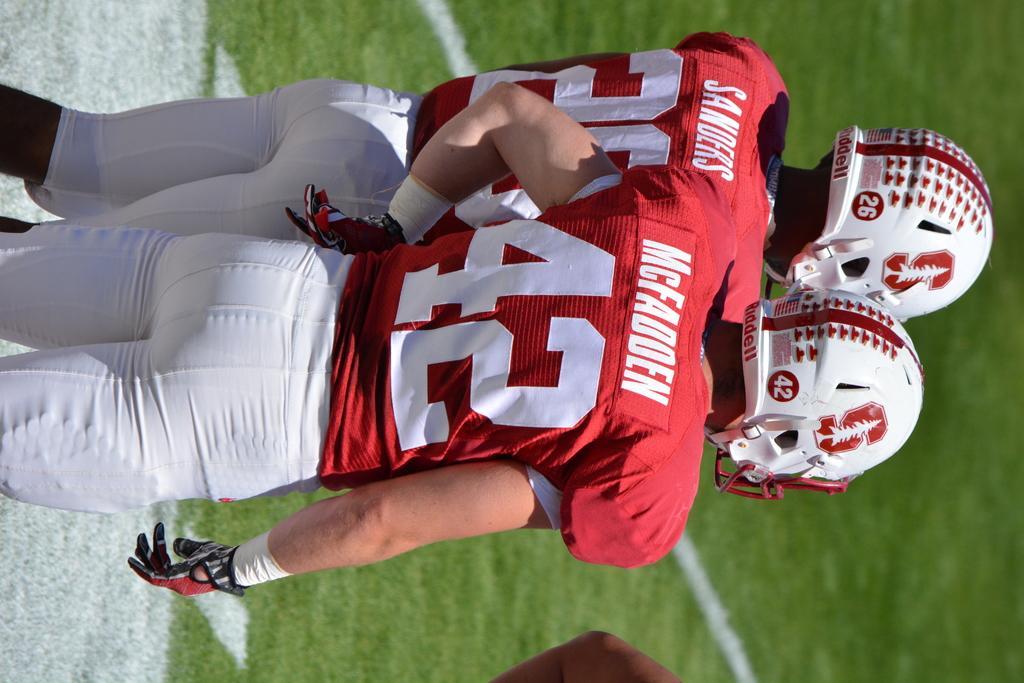Can you describe this image briefly? In this image I can see two persons are wearing red and white dresses. They are wearing helmets. They are in the ground. 